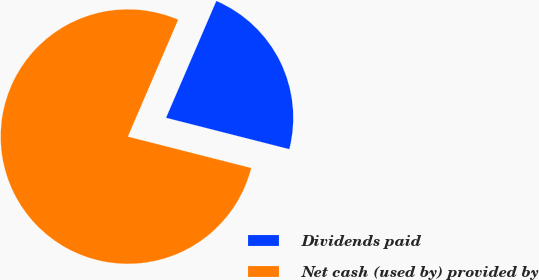Convert chart. <chart><loc_0><loc_0><loc_500><loc_500><pie_chart><fcel>Dividends paid<fcel>Net cash (used by) provided by<nl><fcel>22.5%<fcel>77.5%<nl></chart> 